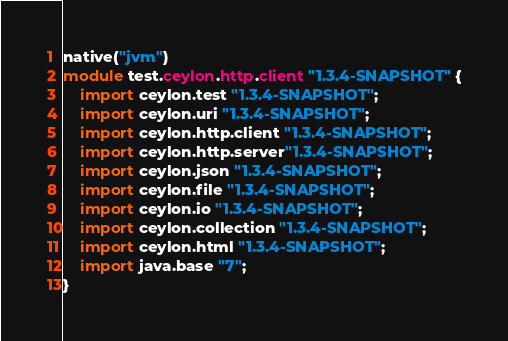<code> <loc_0><loc_0><loc_500><loc_500><_Ceylon_>native("jvm")
module test.ceylon.http.client "1.3.4-SNAPSHOT" {
    import ceylon.test "1.3.4-SNAPSHOT";
    import ceylon.uri "1.3.4-SNAPSHOT";
    import ceylon.http.client "1.3.4-SNAPSHOT";
    import ceylon.http.server"1.3.4-SNAPSHOT";
    import ceylon.json "1.3.4-SNAPSHOT";
    import ceylon.file "1.3.4-SNAPSHOT";
    import ceylon.io "1.3.4-SNAPSHOT";
    import ceylon.collection "1.3.4-SNAPSHOT";
    import ceylon.html "1.3.4-SNAPSHOT";
    import java.base "7";
}
</code> 